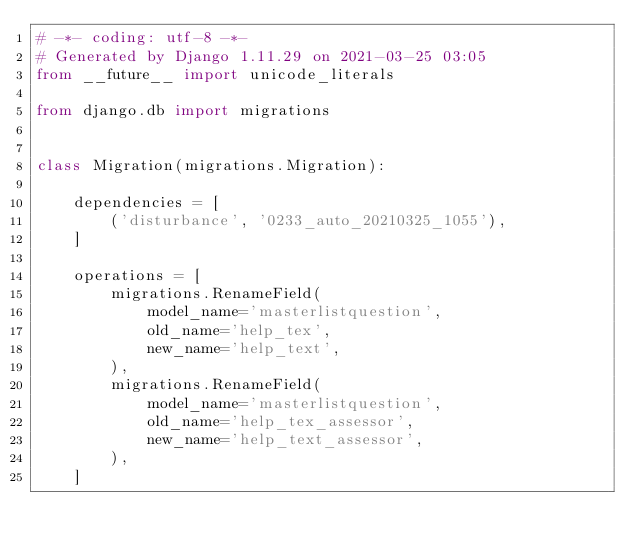<code> <loc_0><loc_0><loc_500><loc_500><_Python_># -*- coding: utf-8 -*-
# Generated by Django 1.11.29 on 2021-03-25 03:05
from __future__ import unicode_literals

from django.db import migrations


class Migration(migrations.Migration):

    dependencies = [
        ('disturbance', '0233_auto_20210325_1055'),
    ]

    operations = [
        migrations.RenameField(
            model_name='masterlistquestion',
            old_name='help_tex',
            new_name='help_text',
        ),
        migrations.RenameField(
            model_name='masterlistquestion',
            old_name='help_tex_assessor',
            new_name='help_text_assessor',
        ),
    ]
</code> 